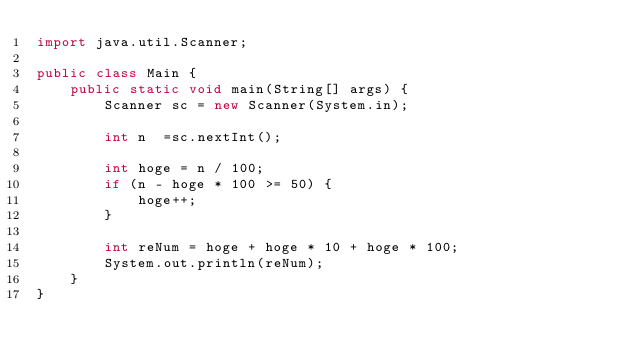Convert code to text. <code><loc_0><loc_0><loc_500><loc_500><_Java_>import java.util.Scanner;

public class Main {
    public static void main(String[] args) {
        Scanner sc = new Scanner(System.in);

        int n  =sc.nextInt();

        int hoge = n / 100;
        if (n - hoge * 100 >= 50) {
            hoge++;
        }
        
        int reNum = hoge + hoge * 10 + hoge * 100;
        System.out.println(reNum);
    }
}</code> 